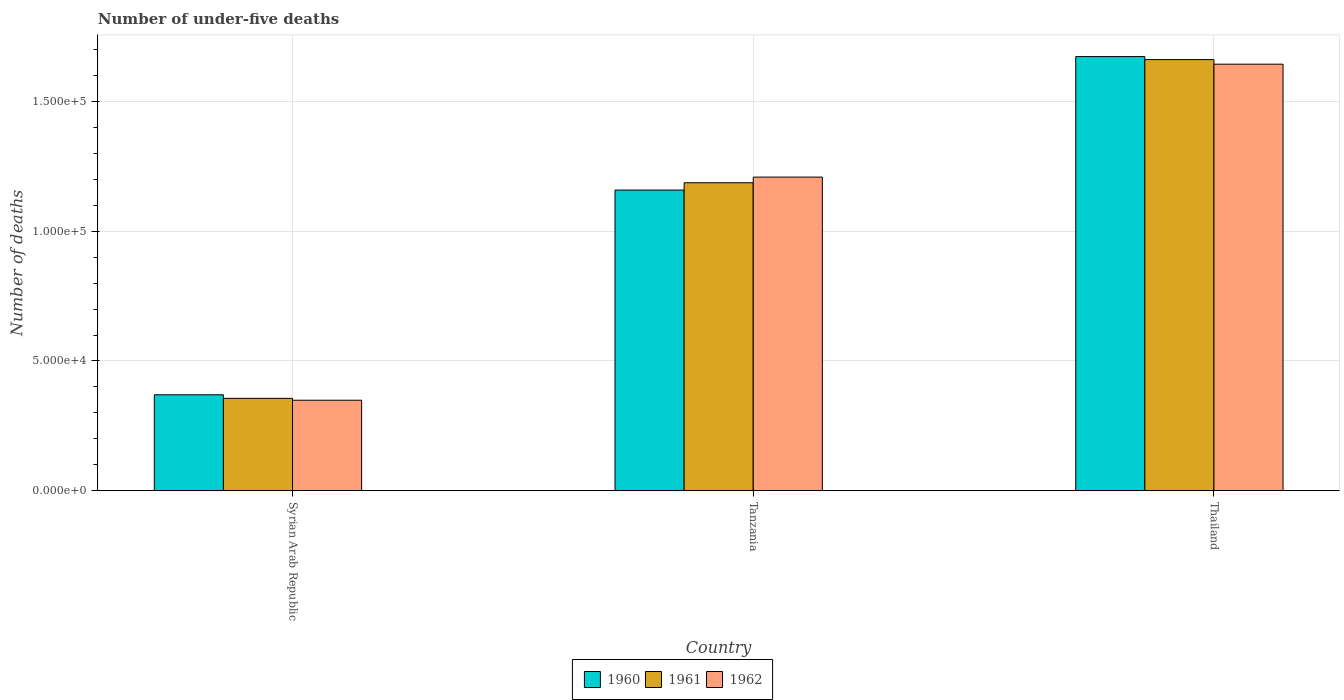How many bars are there on the 3rd tick from the left?
Ensure brevity in your answer.  3. What is the label of the 1st group of bars from the left?
Provide a short and direct response. Syrian Arab Republic. In how many cases, is the number of bars for a given country not equal to the number of legend labels?
Provide a succinct answer. 0. What is the number of under-five deaths in 1962 in Syrian Arab Republic?
Give a very brief answer. 3.49e+04. Across all countries, what is the maximum number of under-five deaths in 1962?
Your answer should be very brief. 1.64e+05. Across all countries, what is the minimum number of under-five deaths in 1962?
Offer a very short reply. 3.49e+04. In which country was the number of under-five deaths in 1961 maximum?
Make the answer very short. Thailand. In which country was the number of under-five deaths in 1960 minimum?
Give a very brief answer. Syrian Arab Republic. What is the total number of under-five deaths in 1961 in the graph?
Give a very brief answer. 3.20e+05. What is the difference between the number of under-five deaths in 1960 in Syrian Arab Republic and that in Thailand?
Ensure brevity in your answer.  -1.30e+05. What is the difference between the number of under-five deaths in 1961 in Syrian Arab Republic and the number of under-five deaths in 1962 in Tanzania?
Keep it short and to the point. -8.52e+04. What is the average number of under-five deaths in 1960 per country?
Offer a terse response. 1.07e+05. What is the difference between the number of under-five deaths of/in 1960 and number of under-five deaths of/in 1961 in Tanzania?
Keep it short and to the point. -2813. What is the ratio of the number of under-five deaths in 1960 in Syrian Arab Republic to that in Tanzania?
Your answer should be compact. 0.32. What is the difference between the highest and the second highest number of under-five deaths in 1960?
Offer a terse response. 1.30e+05. What is the difference between the highest and the lowest number of under-five deaths in 1961?
Give a very brief answer. 1.30e+05. In how many countries, is the number of under-five deaths in 1960 greater than the average number of under-five deaths in 1960 taken over all countries?
Your response must be concise. 2. Is it the case that in every country, the sum of the number of under-five deaths in 1962 and number of under-five deaths in 1961 is greater than the number of under-five deaths in 1960?
Offer a terse response. Yes. Are all the bars in the graph horizontal?
Ensure brevity in your answer.  No. Are the values on the major ticks of Y-axis written in scientific E-notation?
Keep it short and to the point. Yes. Does the graph contain any zero values?
Keep it short and to the point. No. Does the graph contain grids?
Your response must be concise. Yes. Where does the legend appear in the graph?
Keep it short and to the point. Bottom center. How many legend labels are there?
Make the answer very short. 3. What is the title of the graph?
Your answer should be very brief. Number of under-five deaths. What is the label or title of the Y-axis?
Offer a terse response. Number of deaths. What is the Number of deaths in 1960 in Syrian Arab Republic?
Ensure brevity in your answer.  3.70e+04. What is the Number of deaths in 1961 in Syrian Arab Republic?
Ensure brevity in your answer.  3.56e+04. What is the Number of deaths in 1962 in Syrian Arab Republic?
Make the answer very short. 3.49e+04. What is the Number of deaths in 1960 in Tanzania?
Provide a short and direct response. 1.16e+05. What is the Number of deaths in 1961 in Tanzania?
Give a very brief answer. 1.19e+05. What is the Number of deaths in 1962 in Tanzania?
Provide a succinct answer. 1.21e+05. What is the Number of deaths of 1960 in Thailand?
Provide a succinct answer. 1.67e+05. What is the Number of deaths in 1961 in Thailand?
Offer a terse response. 1.66e+05. What is the Number of deaths of 1962 in Thailand?
Offer a terse response. 1.64e+05. Across all countries, what is the maximum Number of deaths of 1960?
Provide a short and direct response. 1.67e+05. Across all countries, what is the maximum Number of deaths in 1961?
Your answer should be very brief. 1.66e+05. Across all countries, what is the maximum Number of deaths of 1962?
Your answer should be very brief. 1.64e+05. Across all countries, what is the minimum Number of deaths of 1960?
Provide a succinct answer. 3.70e+04. Across all countries, what is the minimum Number of deaths in 1961?
Keep it short and to the point. 3.56e+04. Across all countries, what is the minimum Number of deaths in 1962?
Your answer should be compact. 3.49e+04. What is the total Number of deaths in 1960 in the graph?
Provide a short and direct response. 3.20e+05. What is the total Number of deaths of 1961 in the graph?
Your answer should be compact. 3.20e+05. What is the total Number of deaths of 1962 in the graph?
Offer a terse response. 3.20e+05. What is the difference between the Number of deaths of 1960 in Syrian Arab Republic and that in Tanzania?
Keep it short and to the point. -7.89e+04. What is the difference between the Number of deaths in 1961 in Syrian Arab Republic and that in Tanzania?
Provide a short and direct response. -8.30e+04. What is the difference between the Number of deaths of 1962 in Syrian Arab Republic and that in Tanzania?
Give a very brief answer. -8.59e+04. What is the difference between the Number of deaths of 1960 in Syrian Arab Republic and that in Thailand?
Offer a terse response. -1.30e+05. What is the difference between the Number of deaths in 1961 in Syrian Arab Republic and that in Thailand?
Your answer should be compact. -1.30e+05. What is the difference between the Number of deaths of 1962 in Syrian Arab Republic and that in Thailand?
Offer a very short reply. -1.29e+05. What is the difference between the Number of deaths in 1960 in Tanzania and that in Thailand?
Provide a succinct answer. -5.14e+04. What is the difference between the Number of deaths of 1961 in Tanzania and that in Thailand?
Your answer should be very brief. -4.74e+04. What is the difference between the Number of deaths in 1962 in Tanzania and that in Thailand?
Provide a short and direct response. -4.35e+04. What is the difference between the Number of deaths in 1960 in Syrian Arab Republic and the Number of deaths in 1961 in Tanzania?
Your answer should be compact. -8.17e+04. What is the difference between the Number of deaths of 1960 in Syrian Arab Republic and the Number of deaths of 1962 in Tanzania?
Your response must be concise. -8.38e+04. What is the difference between the Number of deaths in 1961 in Syrian Arab Republic and the Number of deaths in 1962 in Tanzania?
Provide a succinct answer. -8.52e+04. What is the difference between the Number of deaths of 1960 in Syrian Arab Republic and the Number of deaths of 1961 in Thailand?
Your answer should be compact. -1.29e+05. What is the difference between the Number of deaths of 1960 in Syrian Arab Republic and the Number of deaths of 1962 in Thailand?
Provide a short and direct response. -1.27e+05. What is the difference between the Number of deaths of 1961 in Syrian Arab Republic and the Number of deaths of 1962 in Thailand?
Offer a terse response. -1.29e+05. What is the difference between the Number of deaths of 1960 in Tanzania and the Number of deaths of 1961 in Thailand?
Your answer should be compact. -5.02e+04. What is the difference between the Number of deaths of 1960 in Tanzania and the Number of deaths of 1962 in Thailand?
Offer a very short reply. -4.85e+04. What is the difference between the Number of deaths of 1961 in Tanzania and the Number of deaths of 1962 in Thailand?
Your response must be concise. -4.57e+04. What is the average Number of deaths of 1960 per country?
Give a very brief answer. 1.07e+05. What is the average Number of deaths of 1961 per country?
Ensure brevity in your answer.  1.07e+05. What is the average Number of deaths of 1962 per country?
Your response must be concise. 1.07e+05. What is the difference between the Number of deaths of 1960 and Number of deaths of 1961 in Syrian Arab Republic?
Provide a short and direct response. 1372. What is the difference between the Number of deaths in 1960 and Number of deaths in 1962 in Syrian Arab Republic?
Make the answer very short. 2094. What is the difference between the Number of deaths in 1961 and Number of deaths in 1962 in Syrian Arab Republic?
Give a very brief answer. 722. What is the difference between the Number of deaths in 1960 and Number of deaths in 1961 in Tanzania?
Offer a terse response. -2813. What is the difference between the Number of deaths of 1960 and Number of deaths of 1962 in Tanzania?
Your response must be concise. -4990. What is the difference between the Number of deaths of 1961 and Number of deaths of 1962 in Tanzania?
Provide a short and direct response. -2177. What is the difference between the Number of deaths of 1960 and Number of deaths of 1961 in Thailand?
Make the answer very short. 1164. What is the difference between the Number of deaths of 1960 and Number of deaths of 1962 in Thailand?
Keep it short and to the point. 2928. What is the difference between the Number of deaths in 1961 and Number of deaths in 1962 in Thailand?
Your response must be concise. 1764. What is the ratio of the Number of deaths of 1960 in Syrian Arab Republic to that in Tanzania?
Your response must be concise. 0.32. What is the ratio of the Number of deaths in 1961 in Syrian Arab Republic to that in Tanzania?
Your response must be concise. 0.3. What is the ratio of the Number of deaths in 1962 in Syrian Arab Republic to that in Tanzania?
Your response must be concise. 0.29. What is the ratio of the Number of deaths of 1960 in Syrian Arab Republic to that in Thailand?
Offer a terse response. 0.22. What is the ratio of the Number of deaths in 1961 in Syrian Arab Republic to that in Thailand?
Give a very brief answer. 0.21. What is the ratio of the Number of deaths of 1962 in Syrian Arab Republic to that in Thailand?
Give a very brief answer. 0.21. What is the ratio of the Number of deaths in 1960 in Tanzania to that in Thailand?
Give a very brief answer. 0.69. What is the ratio of the Number of deaths of 1961 in Tanzania to that in Thailand?
Provide a succinct answer. 0.71. What is the ratio of the Number of deaths of 1962 in Tanzania to that in Thailand?
Provide a succinct answer. 0.74. What is the difference between the highest and the second highest Number of deaths in 1960?
Offer a terse response. 5.14e+04. What is the difference between the highest and the second highest Number of deaths of 1961?
Keep it short and to the point. 4.74e+04. What is the difference between the highest and the second highest Number of deaths in 1962?
Provide a short and direct response. 4.35e+04. What is the difference between the highest and the lowest Number of deaths in 1960?
Offer a very short reply. 1.30e+05. What is the difference between the highest and the lowest Number of deaths of 1961?
Offer a terse response. 1.30e+05. What is the difference between the highest and the lowest Number of deaths of 1962?
Provide a succinct answer. 1.29e+05. 